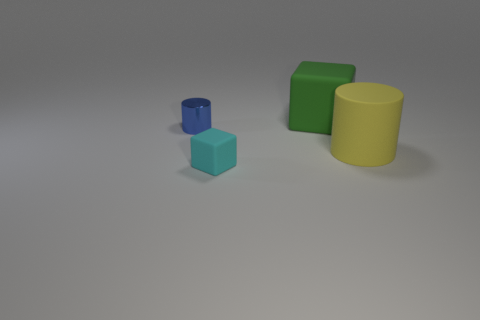How many objects are to the right of the small rubber thing and in front of the yellow thing?
Ensure brevity in your answer.  0. How many cylinders are gray metal objects or blue things?
Ensure brevity in your answer.  1. Is there a small blue cylinder?
Provide a short and direct response. Yes. What number of other objects are the same material as the yellow thing?
Make the answer very short. 2. What material is the object that is the same size as the cyan rubber cube?
Your answer should be very brief. Metal. Does the rubber thing behind the small blue metallic object have the same shape as the tiny blue shiny thing?
Offer a terse response. No. Is the color of the large cylinder the same as the big block?
Offer a very short reply. No. What number of things are cylinders on the left side of the green object or green matte cubes?
Your response must be concise. 2. There is a green thing that is the same size as the yellow rubber cylinder; what shape is it?
Your response must be concise. Cube. Does the object on the right side of the large green matte thing have the same size as the matte cube behind the small rubber block?
Make the answer very short. Yes. 